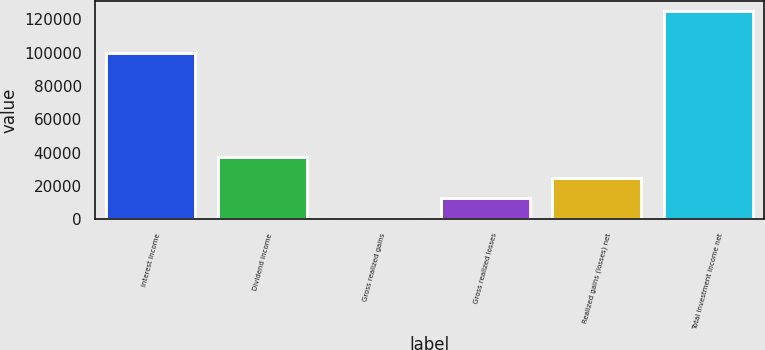Convert chart to OTSL. <chart><loc_0><loc_0><loc_500><loc_500><bar_chart><fcel>Interest income<fcel>Dividend income<fcel>Gross realized gains<fcel>Gross realized losses<fcel>Realized gains (losses) net<fcel>Total investment income net<nl><fcel>100106<fcel>37629.1<fcel>187<fcel>12667.7<fcel>25148.4<fcel>124994<nl></chart> 